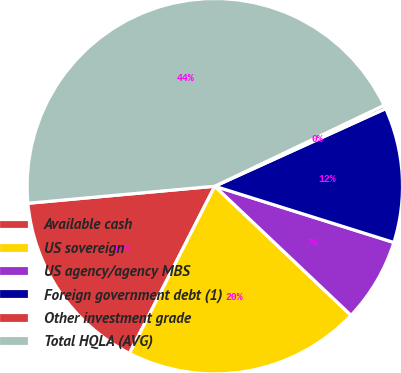Convert chart to OTSL. <chart><loc_0><loc_0><loc_500><loc_500><pie_chart><fcel>Available cash<fcel>US sovereign<fcel>US agency/agency MBS<fcel>Foreign government debt (1)<fcel>Other investment grade<fcel>Total HQLA (AVG)<nl><fcel>16.04%<fcel>20.44%<fcel>7.23%<fcel>11.63%<fcel>0.31%<fcel>44.35%<nl></chart> 